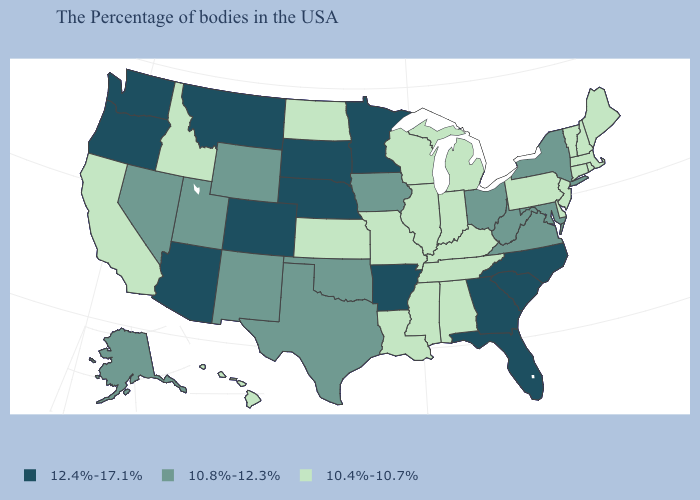Name the states that have a value in the range 12.4%-17.1%?
Short answer required. North Carolina, South Carolina, Florida, Georgia, Arkansas, Minnesota, Nebraska, South Dakota, Colorado, Montana, Arizona, Washington, Oregon. What is the value of Maryland?
Concise answer only. 10.8%-12.3%. Which states have the highest value in the USA?
Be succinct. North Carolina, South Carolina, Florida, Georgia, Arkansas, Minnesota, Nebraska, South Dakota, Colorado, Montana, Arizona, Washington, Oregon. What is the value of Oklahoma?
Answer briefly. 10.8%-12.3%. Name the states that have a value in the range 10.8%-12.3%?
Be succinct. New York, Maryland, Virginia, West Virginia, Ohio, Iowa, Oklahoma, Texas, Wyoming, New Mexico, Utah, Nevada, Alaska. What is the highest value in the USA?
Be succinct. 12.4%-17.1%. Does Arkansas have a higher value than South Dakota?
Keep it brief. No. Among the states that border Massachusetts , does Vermont have the lowest value?
Concise answer only. Yes. What is the value of Pennsylvania?
Concise answer only. 10.4%-10.7%. What is the value of North Dakota?
Answer briefly. 10.4%-10.7%. What is the value of Arizona?
Concise answer only. 12.4%-17.1%. What is the value of North Dakota?
Give a very brief answer. 10.4%-10.7%. What is the lowest value in the West?
Quick response, please. 10.4%-10.7%. Name the states that have a value in the range 12.4%-17.1%?
Keep it brief. North Carolina, South Carolina, Florida, Georgia, Arkansas, Minnesota, Nebraska, South Dakota, Colorado, Montana, Arizona, Washington, Oregon. 